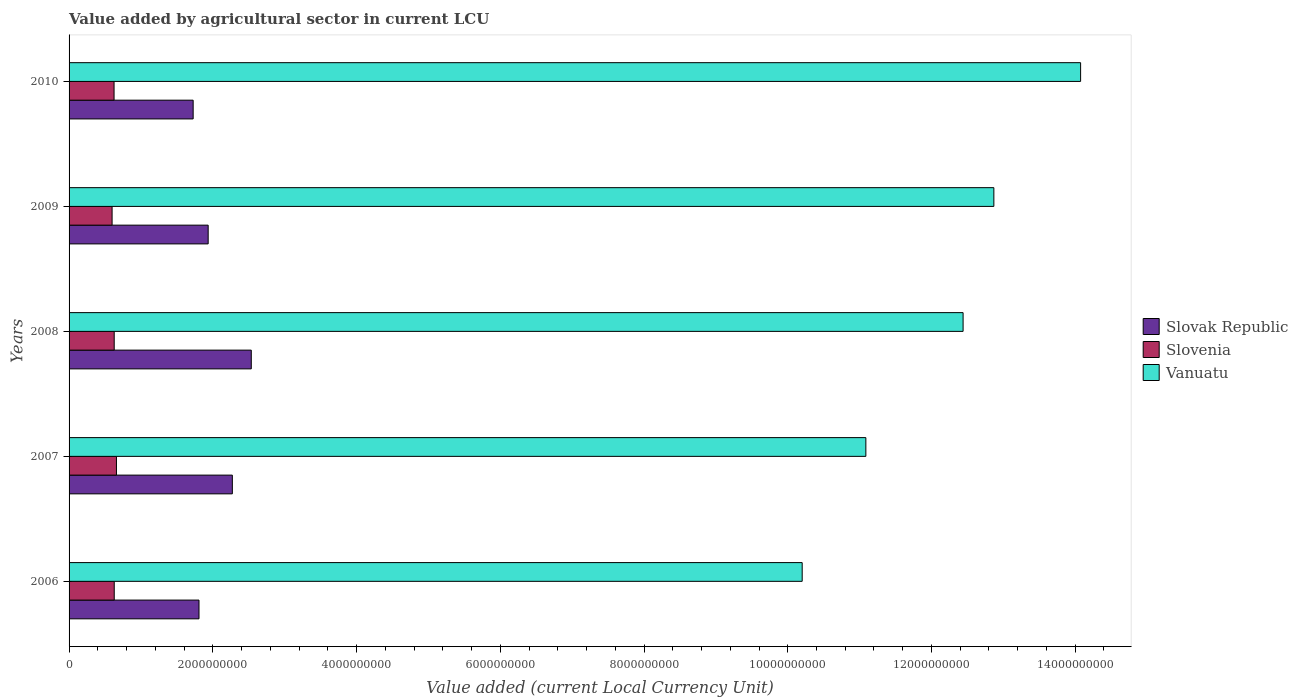Are the number of bars per tick equal to the number of legend labels?
Give a very brief answer. Yes. Are the number of bars on each tick of the Y-axis equal?
Keep it short and to the point. Yes. What is the label of the 4th group of bars from the top?
Your answer should be compact. 2007. In how many cases, is the number of bars for a given year not equal to the number of legend labels?
Ensure brevity in your answer.  0. What is the value added by agricultural sector in Vanuatu in 2008?
Offer a very short reply. 1.24e+1. Across all years, what is the maximum value added by agricultural sector in Vanuatu?
Offer a very short reply. 1.41e+1. Across all years, what is the minimum value added by agricultural sector in Vanuatu?
Ensure brevity in your answer.  1.02e+1. What is the total value added by agricultural sector in Vanuatu in the graph?
Give a very brief answer. 6.07e+1. What is the difference between the value added by agricultural sector in Slovenia in 2008 and that in 2009?
Give a very brief answer. 2.94e+07. What is the difference between the value added by agricultural sector in Vanuatu in 2010 and the value added by agricultural sector in Slovenia in 2008?
Ensure brevity in your answer.  1.34e+1. What is the average value added by agricultural sector in Slovak Republic per year?
Offer a very short reply. 2.06e+09. In the year 2008, what is the difference between the value added by agricultural sector in Slovak Republic and value added by agricultural sector in Slovenia?
Offer a very short reply. 1.91e+09. What is the ratio of the value added by agricultural sector in Slovenia in 2007 to that in 2008?
Keep it short and to the point. 1.05. Is the value added by agricultural sector in Vanuatu in 2006 less than that in 2010?
Provide a succinct answer. Yes. What is the difference between the highest and the second highest value added by agricultural sector in Slovenia?
Your answer should be compact. 3.08e+07. What is the difference between the highest and the lowest value added by agricultural sector in Slovak Republic?
Make the answer very short. 8.09e+08. Is the sum of the value added by agricultural sector in Slovak Republic in 2006 and 2009 greater than the maximum value added by agricultural sector in Vanuatu across all years?
Provide a short and direct response. No. What does the 2nd bar from the top in 2006 represents?
Your response must be concise. Slovenia. What does the 3rd bar from the bottom in 2008 represents?
Your answer should be compact. Vanuatu. How many years are there in the graph?
Provide a succinct answer. 5. What is the difference between two consecutive major ticks on the X-axis?
Provide a short and direct response. 2.00e+09. Are the values on the major ticks of X-axis written in scientific E-notation?
Your answer should be compact. No. Does the graph contain any zero values?
Your answer should be compact. No. What is the title of the graph?
Make the answer very short. Value added by agricultural sector in current LCU. What is the label or title of the X-axis?
Give a very brief answer. Value added (current Local Currency Unit). What is the Value added (current Local Currency Unit) in Slovak Republic in 2006?
Your answer should be compact. 1.81e+09. What is the Value added (current Local Currency Unit) in Slovenia in 2006?
Your answer should be very brief. 6.28e+08. What is the Value added (current Local Currency Unit) of Vanuatu in 2006?
Your answer should be very brief. 1.02e+1. What is the Value added (current Local Currency Unit) of Slovak Republic in 2007?
Make the answer very short. 2.27e+09. What is the Value added (current Local Currency Unit) of Slovenia in 2007?
Provide a succinct answer. 6.59e+08. What is the Value added (current Local Currency Unit) of Vanuatu in 2007?
Give a very brief answer. 1.11e+1. What is the Value added (current Local Currency Unit) of Slovak Republic in 2008?
Your answer should be very brief. 2.54e+09. What is the Value added (current Local Currency Unit) of Slovenia in 2008?
Provide a short and direct response. 6.28e+08. What is the Value added (current Local Currency Unit) in Vanuatu in 2008?
Your response must be concise. 1.24e+1. What is the Value added (current Local Currency Unit) of Slovak Republic in 2009?
Ensure brevity in your answer.  1.94e+09. What is the Value added (current Local Currency Unit) in Slovenia in 2009?
Provide a succinct answer. 5.99e+08. What is the Value added (current Local Currency Unit) of Vanuatu in 2009?
Offer a very short reply. 1.29e+1. What is the Value added (current Local Currency Unit) of Slovak Republic in 2010?
Your response must be concise. 1.73e+09. What is the Value added (current Local Currency Unit) in Slovenia in 2010?
Provide a succinct answer. 6.26e+08. What is the Value added (current Local Currency Unit) in Vanuatu in 2010?
Ensure brevity in your answer.  1.41e+1. Across all years, what is the maximum Value added (current Local Currency Unit) of Slovak Republic?
Keep it short and to the point. 2.54e+09. Across all years, what is the maximum Value added (current Local Currency Unit) in Slovenia?
Provide a succinct answer. 6.59e+08. Across all years, what is the maximum Value added (current Local Currency Unit) in Vanuatu?
Make the answer very short. 1.41e+1. Across all years, what is the minimum Value added (current Local Currency Unit) in Slovak Republic?
Provide a short and direct response. 1.73e+09. Across all years, what is the minimum Value added (current Local Currency Unit) in Slovenia?
Your response must be concise. 5.99e+08. Across all years, what is the minimum Value added (current Local Currency Unit) in Vanuatu?
Ensure brevity in your answer.  1.02e+1. What is the total Value added (current Local Currency Unit) of Slovak Republic in the graph?
Your answer should be compact. 1.03e+1. What is the total Value added (current Local Currency Unit) in Slovenia in the graph?
Make the answer very short. 3.14e+09. What is the total Value added (current Local Currency Unit) of Vanuatu in the graph?
Your response must be concise. 6.07e+1. What is the difference between the Value added (current Local Currency Unit) of Slovak Republic in 2006 and that in 2007?
Give a very brief answer. -4.64e+08. What is the difference between the Value added (current Local Currency Unit) of Slovenia in 2006 and that in 2007?
Give a very brief answer. -3.08e+07. What is the difference between the Value added (current Local Currency Unit) of Vanuatu in 2006 and that in 2007?
Your answer should be very brief. -8.86e+08. What is the difference between the Value added (current Local Currency Unit) in Slovak Republic in 2006 and that in 2008?
Make the answer very short. -7.27e+08. What is the difference between the Value added (current Local Currency Unit) in Slovenia in 2006 and that in 2008?
Provide a short and direct response. 5.10e+05. What is the difference between the Value added (current Local Currency Unit) of Vanuatu in 2006 and that in 2008?
Your answer should be compact. -2.24e+09. What is the difference between the Value added (current Local Currency Unit) in Slovak Republic in 2006 and that in 2009?
Offer a very short reply. -1.28e+08. What is the difference between the Value added (current Local Currency Unit) in Slovenia in 2006 and that in 2009?
Provide a succinct answer. 2.99e+07. What is the difference between the Value added (current Local Currency Unit) of Vanuatu in 2006 and that in 2009?
Offer a terse response. -2.67e+09. What is the difference between the Value added (current Local Currency Unit) of Slovak Republic in 2006 and that in 2010?
Offer a terse response. 8.14e+07. What is the difference between the Value added (current Local Currency Unit) in Slovenia in 2006 and that in 2010?
Your answer should be very brief. 2.47e+06. What is the difference between the Value added (current Local Currency Unit) of Vanuatu in 2006 and that in 2010?
Offer a very short reply. -3.87e+09. What is the difference between the Value added (current Local Currency Unit) in Slovak Republic in 2007 and that in 2008?
Make the answer very short. -2.64e+08. What is the difference between the Value added (current Local Currency Unit) of Slovenia in 2007 and that in 2008?
Offer a very short reply. 3.13e+07. What is the difference between the Value added (current Local Currency Unit) in Vanuatu in 2007 and that in 2008?
Ensure brevity in your answer.  -1.35e+09. What is the difference between the Value added (current Local Currency Unit) in Slovak Republic in 2007 and that in 2009?
Your response must be concise. 3.36e+08. What is the difference between the Value added (current Local Currency Unit) of Slovenia in 2007 and that in 2009?
Keep it short and to the point. 6.07e+07. What is the difference between the Value added (current Local Currency Unit) in Vanuatu in 2007 and that in 2009?
Make the answer very short. -1.78e+09. What is the difference between the Value added (current Local Currency Unit) in Slovak Republic in 2007 and that in 2010?
Make the answer very short. 5.45e+08. What is the difference between the Value added (current Local Currency Unit) of Slovenia in 2007 and that in 2010?
Make the answer very short. 3.32e+07. What is the difference between the Value added (current Local Currency Unit) of Vanuatu in 2007 and that in 2010?
Your response must be concise. -2.99e+09. What is the difference between the Value added (current Local Currency Unit) in Slovak Republic in 2008 and that in 2009?
Give a very brief answer. 6.00e+08. What is the difference between the Value added (current Local Currency Unit) of Slovenia in 2008 and that in 2009?
Give a very brief answer. 2.94e+07. What is the difference between the Value added (current Local Currency Unit) of Vanuatu in 2008 and that in 2009?
Provide a succinct answer. -4.28e+08. What is the difference between the Value added (current Local Currency Unit) in Slovak Republic in 2008 and that in 2010?
Offer a terse response. 8.09e+08. What is the difference between the Value added (current Local Currency Unit) of Slovenia in 2008 and that in 2010?
Provide a short and direct response. 1.96e+06. What is the difference between the Value added (current Local Currency Unit) in Vanuatu in 2008 and that in 2010?
Your answer should be very brief. -1.64e+09. What is the difference between the Value added (current Local Currency Unit) of Slovak Republic in 2009 and that in 2010?
Keep it short and to the point. 2.09e+08. What is the difference between the Value added (current Local Currency Unit) in Slovenia in 2009 and that in 2010?
Offer a terse response. -2.74e+07. What is the difference between the Value added (current Local Currency Unit) in Vanuatu in 2009 and that in 2010?
Your response must be concise. -1.21e+09. What is the difference between the Value added (current Local Currency Unit) of Slovak Republic in 2006 and the Value added (current Local Currency Unit) of Slovenia in 2007?
Make the answer very short. 1.15e+09. What is the difference between the Value added (current Local Currency Unit) in Slovak Republic in 2006 and the Value added (current Local Currency Unit) in Vanuatu in 2007?
Make the answer very short. -9.28e+09. What is the difference between the Value added (current Local Currency Unit) in Slovenia in 2006 and the Value added (current Local Currency Unit) in Vanuatu in 2007?
Provide a succinct answer. -1.05e+1. What is the difference between the Value added (current Local Currency Unit) in Slovak Republic in 2006 and the Value added (current Local Currency Unit) in Slovenia in 2008?
Give a very brief answer. 1.18e+09. What is the difference between the Value added (current Local Currency Unit) of Slovak Republic in 2006 and the Value added (current Local Currency Unit) of Vanuatu in 2008?
Keep it short and to the point. -1.06e+1. What is the difference between the Value added (current Local Currency Unit) in Slovenia in 2006 and the Value added (current Local Currency Unit) in Vanuatu in 2008?
Make the answer very short. -1.18e+1. What is the difference between the Value added (current Local Currency Unit) in Slovak Republic in 2006 and the Value added (current Local Currency Unit) in Slovenia in 2009?
Give a very brief answer. 1.21e+09. What is the difference between the Value added (current Local Currency Unit) in Slovak Republic in 2006 and the Value added (current Local Currency Unit) in Vanuatu in 2009?
Give a very brief answer. -1.11e+1. What is the difference between the Value added (current Local Currency Unit) in Slovenia in 2006 and the Value added (current Local Currency Unit) in Vanuatu in 2009?
Provide a succinct answer. -1.22e+1. What is the difference between the Value added (current Local Currency Unit) of Slovak Republic in 2006 and the Value added (current Local Currency Unit) of Slovenia in 2010?
Keep it short and to the point. 1.18e+09. What is the difference between the Value added (current Local Currency Unit) in Slovak Republic in 2006 and the Value added (current Local Currency Unit) in Vanuatu in 2010?
Give a very brief answer. -1.23e+1. What is the difference between the Value added (current Local Currency Unit) in Slovenia in 2006 and the Value added (current Local Currency Unit) in Vanuatu in 2010?
Make the answer very short. -1.34e+1. What is the difference between the Value added (current Local Currency Unit) of Slovak Republic in 2007 and the Value added (current Local Currency Unit) of Slovenia in 2008?
Your answer should be very brief. 1.64e+09. What is the difference between the Value added (current Local Currency Unit) in Slovak Republic in 2007 and the Value added (current Local Currency Unit) in Vanuatu in 2008?
Your answer should be very brief. -1.02e+1. What is the difference between the Value added (current Local Currency Unit) in Slovenia in 2007 and the Value added (current Local Currency Unit) in Vanuatu in 2008?
Make the answer very short. -1.18e+1. What is the difference between the Value added (current Local Currency Unit) in Slovak Republic in 2007 and the Value added (current Local Currency Unit) in Slovenia in 2009?
Ensure brevity in your answer.  1.67e+09. What is the difference between the Value added (current Local Currency Unit) in Slovak Republic in 2007 and the Value added (current Local Currency Unit) in Vanuatu in 2009?
Keep it short and to the point. -1.06e+1. What is the difference between the Value added (current Local Currency Unit) in Slovenia in 2007 and the Value added (current Local Currency Unit) in Vanuatu in 2009?
Your answer should be very brief. -1.22e+1. What is the difference between the Value added (current Local Currency Unit) in Slovak Republic in 2007 and the Value added (current Local Currency Unit) in Slovenia in 2010?
Your answer should be compact. 1.65e+09. What is the difference between the Value added (current Local Currency Unit) in Slovak Republic in 2007 and the Value added (current Local Currency Unit) in Vanuatu in 2010?
Give a very brief answer. -1.18e+1. What is the difference between the Value added (current Local Currency Unit) in Slovenia in 2007 and the Value added (current Local Currency Unit) in Vanuatu in 2010?
Ensure brevity in your answer.  -1.34e+1. What is the difference between the Value added (current Local Currency Unit) of Slovak Republic in 2008 and the Value added (current Local Currency Unit) of Slovenia in 2009?
Your answer should be very brief. 1.94e+09. What is the difference between the Value added (current Local Currency Unit) of Slovak Republic in 2008 and the Value added (current Local Currency Unit) of Vanuatu in 2009?
Your answer should be very brief. -1.03e+1. What is the difference between the Value added (current Local Currency Unit) in Slovenia in 2008 and the Value added (current Local Currency Unit) in Vanuatu in 2009?
Your answer should be very brief. -1.22e+1. What is the difference between the Value added (current Local Currency Unit) of Slovak Republic in 2008 and the Value added (current Local Currency Unit) of Slovenia in 2010?
Your response must be concise. 1.91e+09. What is the difference between the Value added (current Local Currency Unit) in Slovak Republic in 2008 and the Value added (current Local Currency Unit) in Vanuatu in 2010?
Your answer should be compact. -1.15e+1. What is the difference between the Value added (current Local Currency Unit) of Slovenia in 2008 and the Value added (current Local Currency Unit) of Vanuatu in 2010?
Make the answer very short. -1.34e+1. What is the difference between the Value added (current Local Currency Unit) of Slovak Republic in 2009 and the Value added (current Local Currency Unit) of Slovenia in 2010?
Keep it short and to the point. 1.31e+09. What is the difference between the Value added (current Local Currency Unit) of Slovak Republic in 2009 and the Value added (current Local Currency Unit) of Vanuatu in 2010?
Provide a short and direct response. -1.21e+1. What is the difference between the Value added (current Local Currency Unit) of Slovenia in 2009 and the Value added (current Local Currency Unit) of Vanuatu in 2010?
Keep it short and to the point. -1.35e+1. What is the average Value added (current Local Currency Unit) of Slovak Republic per year?
Keep it short and to the point. 2.06e+09. What is the average Value added (current Local Currency Unit) in Slovenia per year?
Provide a succinct answer. 6.28e+08. What is the average Value added (current Local Currency Unit) of Vanuatu per year?
Provide a succinct answer. 1.21e+1. In the year 2006, what is the difference between the Value added (current Local Currency Unit) of Slovak Republic and Value added (current Local Currency Unit) of Slovenia?
Ensure brevity in your answer.  1.18e+09. In the year 2006, what is the difference between the Value added (current Local Currency Unit) of Slovak Republic and Value added (current Local Currency Unit) of Vanuatu?
Your response must be concise. -8.39e+09. In the year 2006, what is the difference between the Value added (current Local Currency Unit) of Slovenia and Value added (current Local Currency Unit) of Vanuatu?
Provide a short and direct response. -9.57e+09. In the year 2007, what is the difference between the Value added (current Local Currency Unit) in Slovak Republic and Value added (current Local Currency Unit) in Slovenia?
Give a very brief answer. 1.61e+09. In the year 2007, what is the difference between the Value added (current Local Currency Unit) of Slovak Republic and Value added (current Local Currency Unit) of Vanuatu?
Your response must be concise. -8.82e+09. In the year 2007, what is the difference between the Value added (current Local Currency Unit) in Slovenia and Value added (current Local Currency Unit) in Vanuatu?
Your answer should be very brief. -1.04e+1. In the year 2008, what is the difference between the Value added (current Local Currency Unit) in Slovak Republic and Value added (current Local Currency Unit) in Slovenia?
Offer a very short reply. 1.91e+09. In the year 2008, what is the difference between the Value added (current Local Currency Unit) in Slovak Republic and Value added (current Local Currency Unit) in Vanuatu?
Give a very brief answer. -9.90e+09. In the year 2008, what is the difference between the Value added (current Local Currency Unit) of Slovenia and Value added (current Local Currency Unit) of Vanuatu?
Ensure brevity in your answer.  -1.18e+1. In the year 2009, what is the difference between the Value added (current Local Currency Unit) of Slovak Republic and Value added (current Local Currency Unit) of Slovenia?
Your answer should be very brief. 1.34e+09. In the year 2009, what is the difference between the Value added (current Local Currency Unit) in Slovak Republic and Value added (current Local Currency Unit) in Vanuatu?
Offer a terse response. -1.09e+1. In the year 2009, what is the difference between the Value added (current Local Currency Unit) of Slovenia and Value added (current Local Currency Unit) of Vanuatu?
Your response must be concise. -1.23e+1. In the year 2010, what is the difference between the Value added (current Local Currency Unit) of Slovak Republic and Value added (current Local Currency Unit) of Slovenia?
Keep it short and to the point. 1.10e+09. In the year 2010, what is the difference between the Value added (current Local Currency Unit) in Slovak Republic and Value added (current Local Currency Unit) in Vanuatu?
Your answer should be compact. -1.23e+1. In the year 2010, what is the difference between the Value added (current Local Currency Unit) in Slovenia and Value added (current Local Currency Unit) in Vanuatu?
Your answer should be compact. -1.34e+1. What is the ratio of the Value added (current Local Currency Unit) of Slovak Republic in 2006 to that in 2007?
Give a very brief answer. 0.8. What is the ratio of the Value added (current Local Currency Unit) in Slovenia in 2006 to that in 2007?
Provide a succinct answer. 0.95. What is the ratio of the Value added (current Local Currency Unit) in Vanuatu in 2006 to that in 2007?
Your answer should be compact. 0.92. What is the ratio of the Value added (current Local Currency Unit) of Slovak Republic in 2006 to that in 2008?
Make the answer very short. 0.71. What is the ratio of the Value added (current Local Currency Unit) in Slovenia in 2006 to that in 2008?
Your answer should be very brief. 1. What is the ratio of the Value added (current Local Currency Unit) in Vanuatu in 2006 to that in 2008?
Make the answer very short. 0.82. What is the ratio of the Value added (current Local Currency Unit) of Slovak Republic in 2006 to that in 2009?
Offer a terse response. 0.93. What is the ratio of the Value added (current Local Currency Unit) in Vanuatu in 2006 to that in 2009?
Make the answer very short. 0.79. What is the ratio of the Value added (current Local Currency Unit) of Slovak Republic in 2006 to that in 2010?
Provide a succinct answer. 1.05. What is the ratio of the Value added (current Local Currency Unit) of Slovenia in 2006 to that in 2010?
Offer a very short reply. 1. What is the ratio of the Value added (current Local Currency Unit) of Vanuatu in 2006 to that in 2010?
Give a very brief answer. 0.72. What is the ratio of the Value added (current Local Currency Unit) in Slovak Republic in 2007 to that in 2008?
Provide a short and direct response. 0.9. What is the ratio of the Value added (current Local Currency Unit) of Slovenia in 2007 to that in 2008?
Keep it short and to the point. 1.05. What is the ratio of the Value added (current Local Currency Unit) of Vanuatu in 2007 to that in 2008?
Provide a short and direct response. 0.89. What is the ratio of the Value added (current Local Currency Unit) of Slovak Republic in 2007 to that in 2009?
Your answer should be compact. 1.17. What is the ratio of the Value added (current Local Currency Unit) of Slovenia in 2007 to that in 2009?
Your answer should be compact. 1.1. What is the ratio of the Value added (current Local Currency Unit) of Vanuatu in 2007 to that in 2009?
Your answer should be very brief. 0.86. What is the ratio of the Value added (current Local Currency Unit) in Slovak Republic in 2007 to that in 2010?
Make the answer very short. 1.32. What is the ratio of the Value added (current Local Currency Unit) of Slovenia in 2007 to that in 2010?
Ensure brevity in your answer.  1.05. What is the ratio of the Value added (current Local Currency Unit) in Vanuatu in 2007 to that in 2010?
Your response must be concise. 0.79. What is the ratio of the Value added (current Local Currency Unit) in Slovak Republic in 2008 to that in 2009?
Provide a short and direct response. 1.31. What is the ratio of the Value added (current Local Currency Unit) in Slovenia in 2008 to that in 2009?
Ensure brevity in your answer.  1.05. What is the ratio of the Value added (current Local Currency Unit) in Vanuatu in 2008 to that in 2009?
Give a very brief answer. 0.97. What is the ratio of the Value added (current Local Currency Unit) in Slovak Republic in 2008 to that in 2010?
Make the answer very short. 1.47. What is the ratio of the Value added (current Local Currency Unit) in Vanuatu in 2008 to that in 2010?
Make the answer very short. 0.88. What is the ratio of the Value added (current Local Currency Unit) of Slovak Republic in 2009 to that in 2010?
Provide a short and direct response. 1.12. What is the ratio of the Value added (current Local Currency Unit) in Slovenia in 2009 to that in 2010?
Provide a short and direct response. 0.96. What is the ratio of the Value added (current Local Currency Unit) of Vanuatu in 2009 to that in 2010?
Give a very brief answer. 0.91. What is the difference between the highest and the second highest Value added (current Local Currency Unit) of Slovak Republic?
Your response must be concise. 2.64e+08. What is the difference between the highest and the second highest Value added (current Local Currency Unit) of Slovenia?
Your response must be concise. 3.08e+07. What is the difference between the highest and the second highest Value added (current Local Currency Unit) of Vanuatu?
Offer a very short reply. 1.21e+09. What is the difference between the highest and the lowest Value added (current Local Currency Unit) in Slovak Republic?
Give a very brief answer. 8.09e+08. What is the difference between the highest and the lowest Value added (current Local Currency Unit) of Slovenia?
Ensure brevity in your answer.  6.07e+07. What is the difference between the highest and the lowest Value added (current Local Currency Unit) of Vanuatu?
Provide a succinct answer. 3.87e+09. 